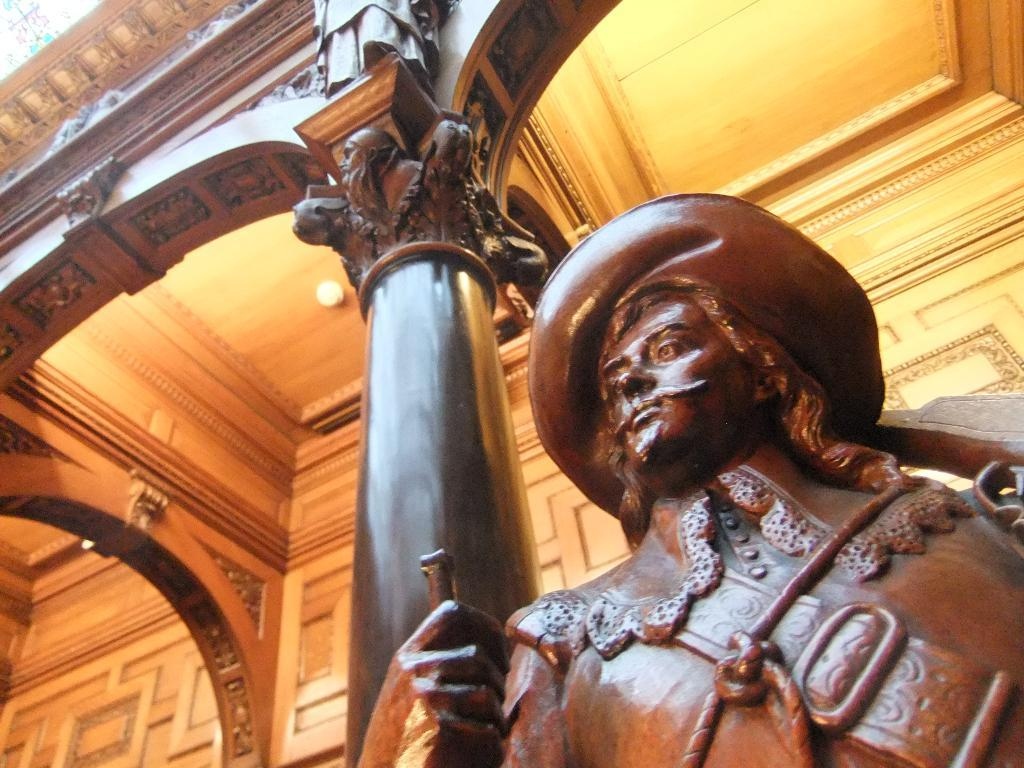What type of building is shown in the image? The image appears to depict a palace. Can you identify any specific architectural features in the image? Yes, there is a pillar in the image. What is located beside the pillar? There is a sculpture of a man beside the pillar. Are there any decorative elements on the pillar? Yes, carvings are present on the pillar. How does the chicken fear the palace in the image? There is no chicken present in the image, so it cannot fear the palace. 